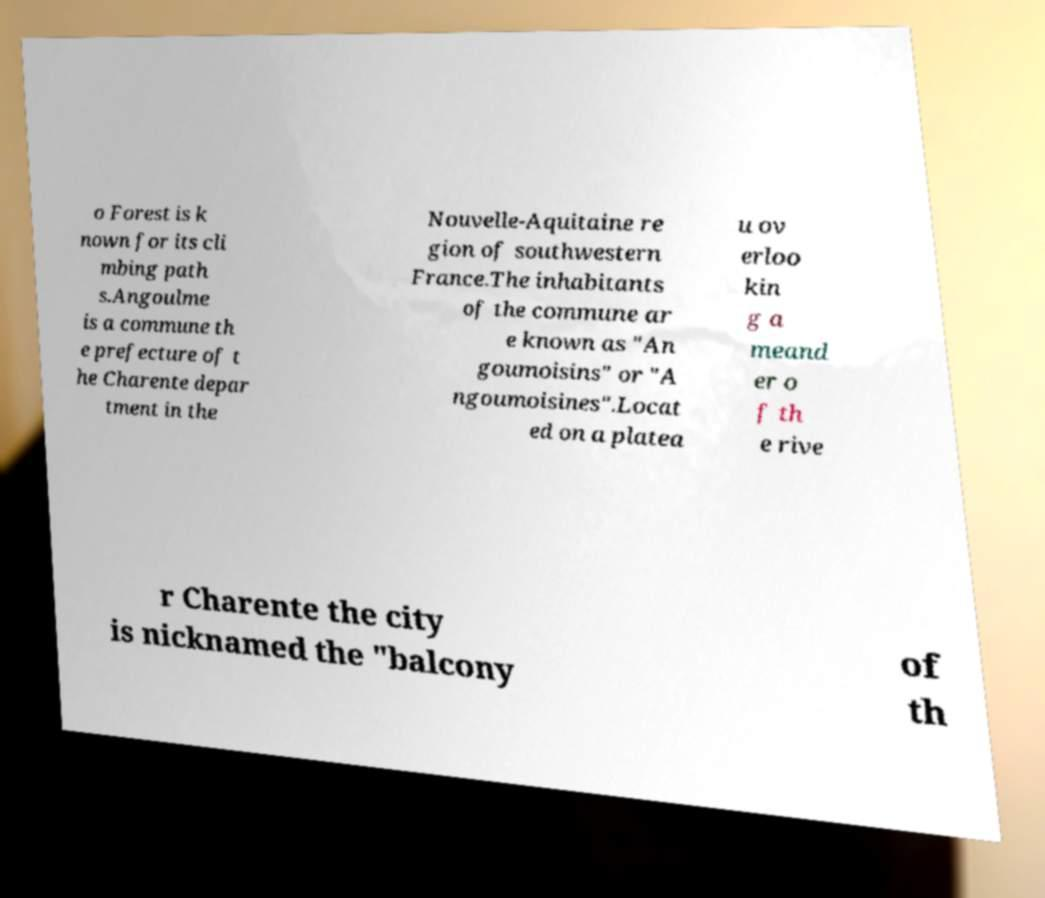Please read and relay the text visible in this image. What does it say? o Forest is k nown for its cli mbing path s.Angoulme is a commune th e prefecture of t he Charente depar tment in the Nouvelle-Aquitaine re gion of southwestern France.The inhabitants of the commune ar e known as "An goumoisins" or "A ngoumoisines".Locat ed on a platea u ov erloo kin g a meand er o f th e rive r Charente the city is nicknamed the "balcony of th 